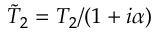<formula> <loc_0><loc_0><loc_500><loc_500>\tilde { T } _ { 2 } = T _ { 2 } / ( 1 + i \alpha )</formula> 